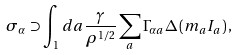Convert formula to latex. <formula><loc_0><loc_0><loc_500><loc_500>\sigma _ { \alpha } \supset \int _ { 1 } d a \frac { \gamma } { \rho ^ { 1 / 2 } } \sum _ { a } \Gamma _ { \alpha a } \Delta \left ( m _ { a } I _ { a } \right ) ,</formula> 